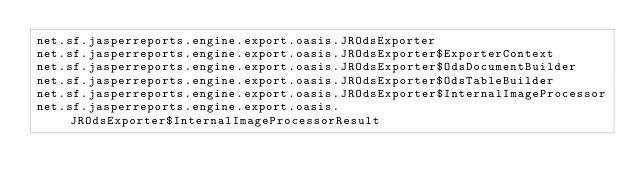Convert code to text. <code><loc_0><loc_0><loc_500><loc_500><_Rust_>net.sf.jasperreports.engine.export.oasis.JROdsExporter
net.sf.jasperreports.engine.export.oasis.JROdsExporter$ExporterContext
net.sf.jasperreports.engine.export.oasis.JROdsExporter$OdsDocumentBuilder
net.sf.jasperreports.engine.export.oasis.JROdsExporter$OdsTableBuilder
net.sf.jasperreports.engine.export.oasis.JROdsExporter$InternalImageProcessor
net.sf.jasperreports.engine.export.oasis.JROdsExporter$InternalImageProcessorResult
</code> 